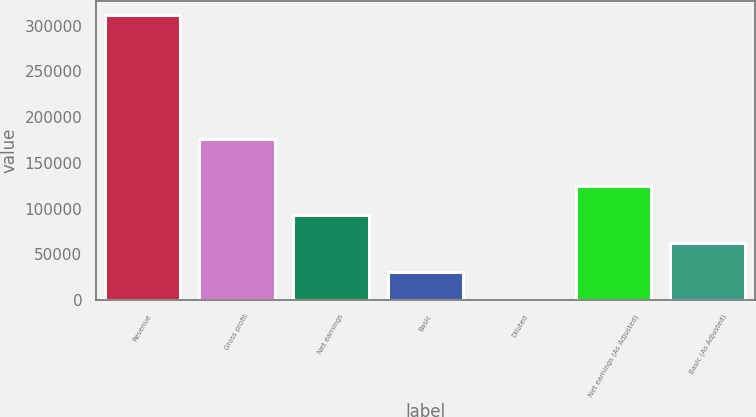Convert chart to OTSL. <chart><loc_0><loc_0><loc_500><loc_500><bar_chart><fcel>Revenue<fcel>Gross profit<fcel>Net earnings<fcel>Basic<fcel>Diluted<fcel>Net earnings (As Adjusted)<fcel>Basic (As Adjusted)<nl><fcel>311560<fcel>176049<fcel>93468.3<fcel>31156.3<fcel>0.38<fcel>124624<fcel>62312.3<nl></chart> 